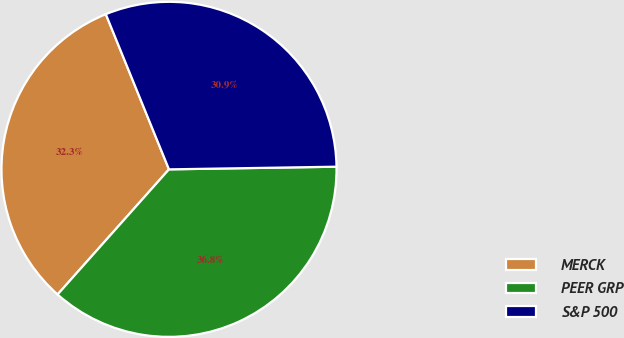<chart> <loc_0><loc_0><loc_500><loc_500><pie_chart><fcel>MERCK<fcel>PEER GRP<fcel>S&P 500<nl><fcel>32.27%<fcel>36.83%<fcel>30.9%<nl></chart> 